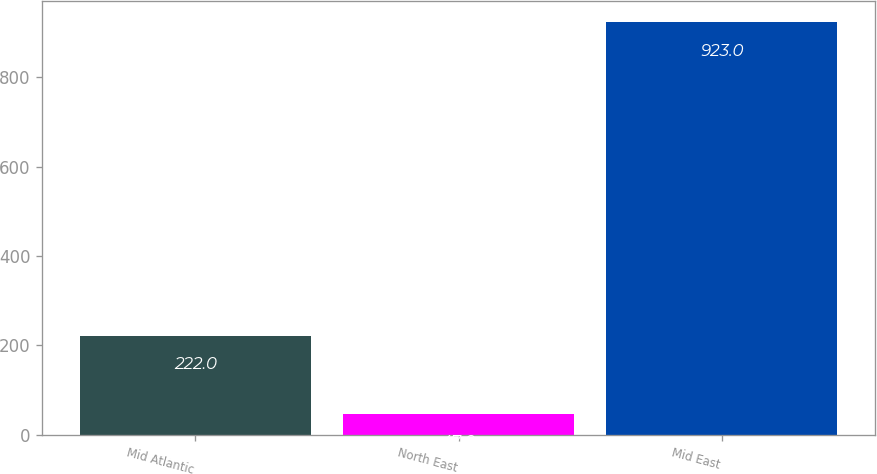<chart> <loc_0><loc_0><loc_500><loc_500><bar_chart><fcel>Mid Atlantic<fcel>North East<fcel>Mid East<nl><fcel>222<fcel>47<fcel>923<nl></chart> 